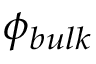Convert formula to latex. <formula><loc_0><loc_0><loc_500><loc_500>\phi _ { b u l k }</formula> 